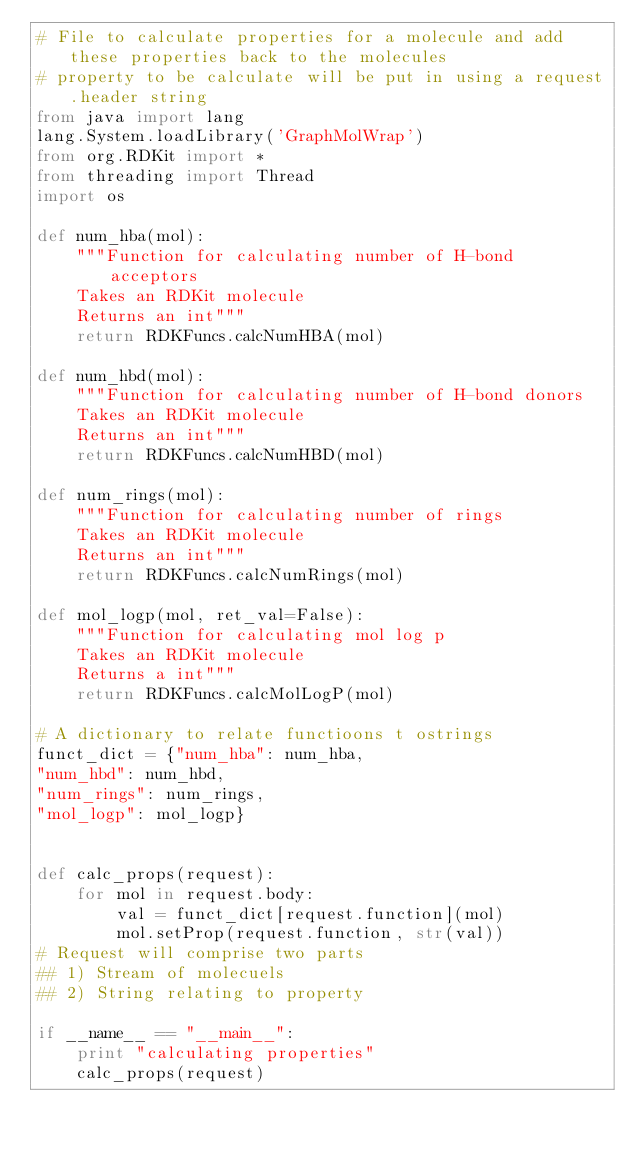Convert code to text. <code><loc_0><loc_0><loc_500><loc_500><_Python_># File to calculate properties for a molecule and add these properties back to the molecules
# property to be calculate will be put in using a request.header string
from java import lang
lang.System.loadLibrary('GraphMolWrap')
from org.RDKit import *
from threading import Thread
import os

def num_hba(mol):
    """Function for calculating number of H-bond acceptors
    Takes an RDKit molecule
    Returns an int"""
    return RDKFuncs.calcNumHBA(mol)

def num_hbd(mol):
    """Function for calculating number of H-bond donors
    Takes an RDKit molecule
    Returns an int"""
    return RDKFuncs.calcNumHBD(mol)

def num_rings(mol):
    """Function for calculating number of rings
    Takes an RDKit molecule
    Returns an int"""
    return RDKFuncs.calcNumRings(mol)

def mol_logp(mol, ret_val=False):
    """Function for calculating mol log p
    Takes an RDKit molecule
    Returns a int"""
    return RDKFuncs.calcMolLogP(mol)

# A dictionary to relate functioons t ostrings
funct_dict = {"num_hba": num_hba,
"num_hbd": num_hbd,
"num_rings": num_rings,
"mol_logp": mol_logp}


def calc_props(request):
    for mol in request.body:
        val = funct_dict[request.function](mol)
        mol.setProp(request.function, str(val))
# Request will comprise two parts
## 1) Stream of molecuels
## 2) String relating to property

if __name__ == "__main__":
    print "calculating properties"
    calc_props(request)
</code> 